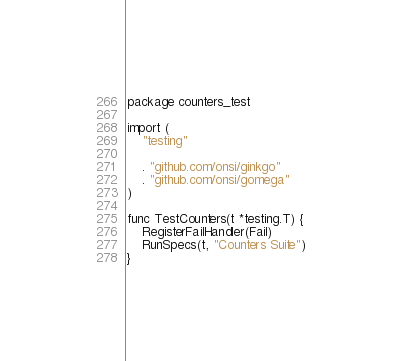<code> <loc_0><loc_0><loc_500><loc_500><_Go_>package counters_test

import (
	"testing"

	. "github.com/onsi/ginkgo"
	. "github.com/onsi/gomega"
)

func TestCounters(t *testing.T) {
	RegisterFailHandler(Fail)
	RunSpecs(t, "Counters Suite")
}
</code> 